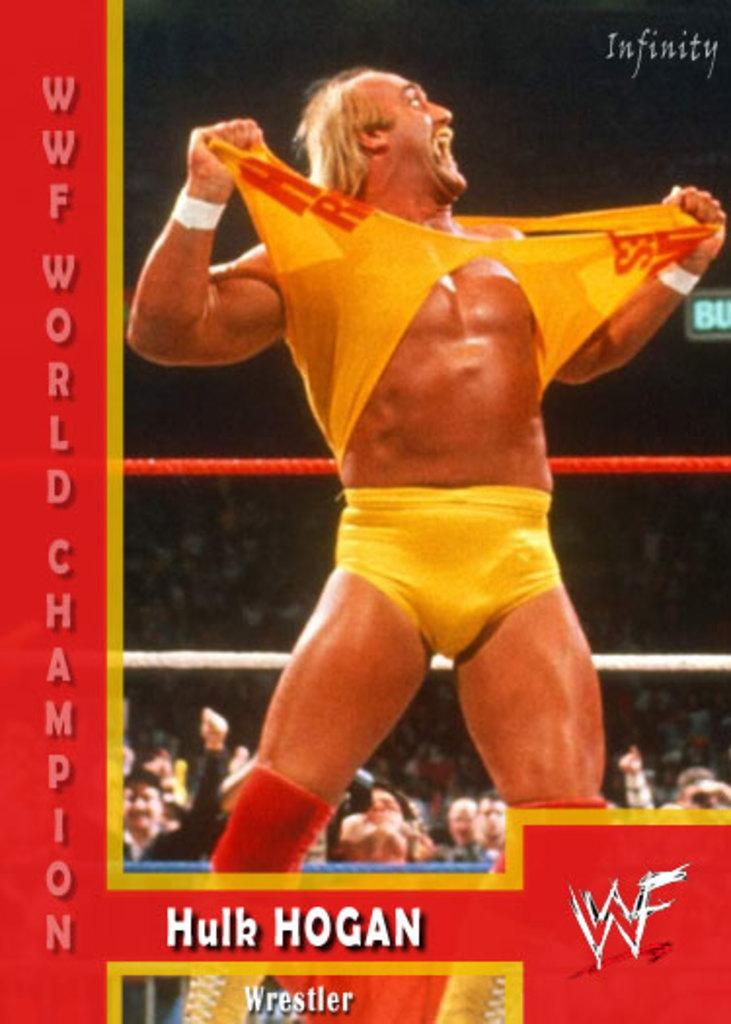Provide a one-sentence caption for the provided image. The wrestler Hulk Hogan tears his top open during the WWF World Championships. 